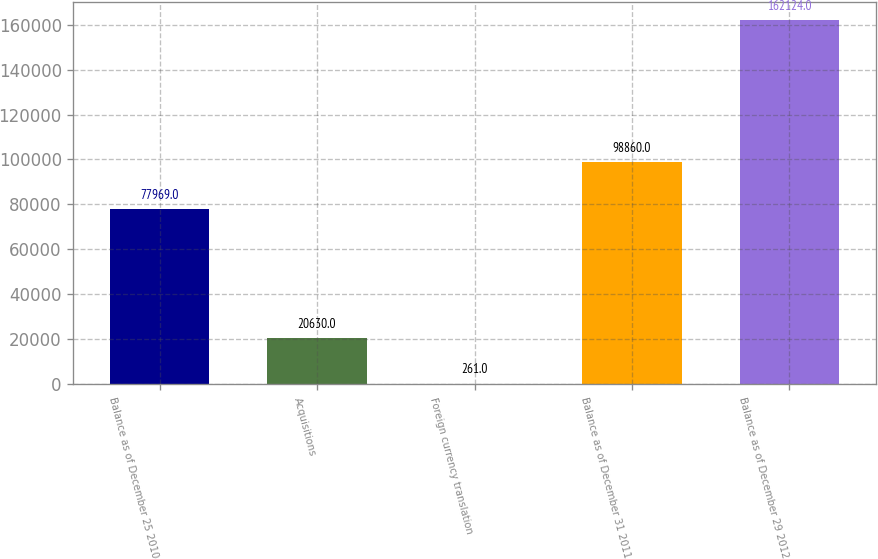<chart> <loc_0><loc_0><loc_500><loc_500><bar_chart><fcel>Balance as of December 25 2010<fcel>Acquisitions<fcel>Foreign currency translation<fcel>Balance as of December 31 2011<fcel>Balance as of December 29 2012<nl><fcel>77969<fcel>20630<fcel>261<fcel>98860<fcel>162124<nl></chart> 